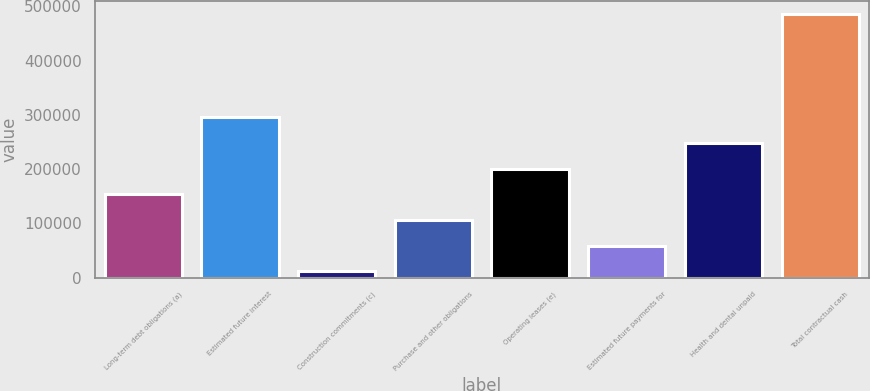<chart> <loc_0><loc_0><loc_500><loc_500><bar_chart><fcel>Long-term debt obligations (a)<fcel>Estimated future interest<fcel>Construction commitments (c)<fcel>Purchase and other obligations<fcel>Operating leases (e)<fcel>Estimated future payments for<fcel>Health and dental unpaid<fcel>Total contractual cash<nl><fcel>153596<fcel>295822<fcel>11370<fcel>106187<fcel>201005<fcel>58778.7<fcel>248414<fcel>485457<nl></chart> 